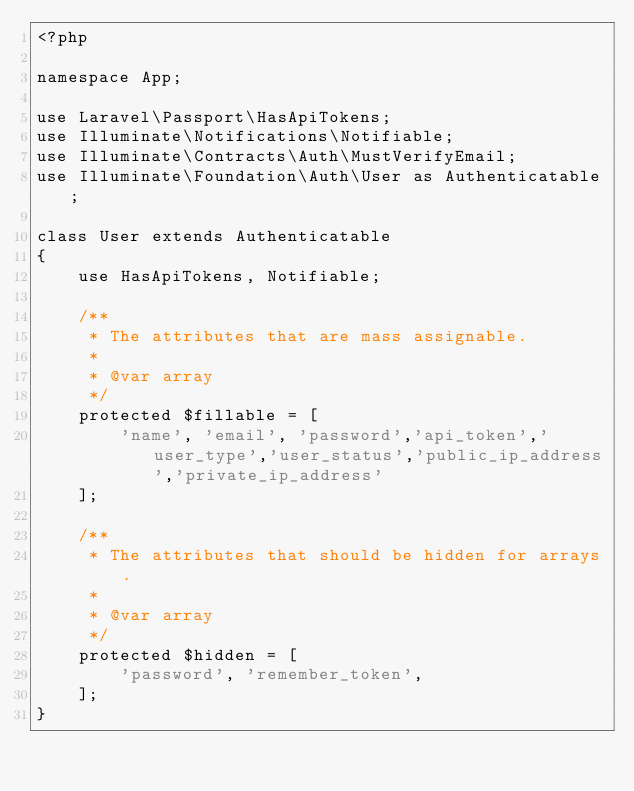<code> <loc_0><loc_0><loc_500><loc_500><_PHP_><?php

namespace App;

use Laravel\Passport\HasApiTokens;
use Illuminate\Notifications\Notifiable;
use Illuminate\Contracts\Auth\MustVerifyEmail;
use Illuminate\Foundation\Auth\User as Authenticatable;

class User extends Authenticatable
{
    use HasApiTokens, Notifiable;

    /**
     * The attributes that are mass assignable.
     *
     * @var array
     */
    protected $fillable = [
        'name', 'email', 'password','api_token','user_type','user_status','public_ip_address','private_ip_address'
    ];

    /**
     * The attributes that should be hidden for arrays.
     *
     * @var array
     */
    protected $hidden = [
        'password', 'remember_token',
    ];
}
</code> 